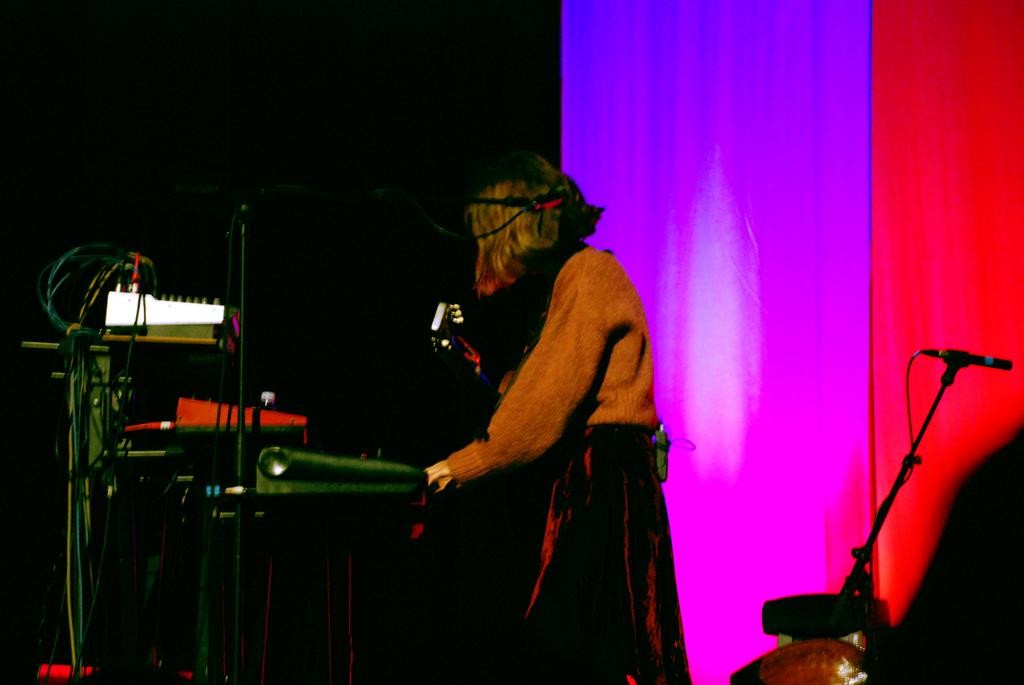What is the person in the image holding? The person is holding a guitar in the image. What else can be seen in the image besides the person with the guitar? There are musical instruments and a cloth in the image. How would you describe the lighting in the image? The background of the image is dark. Can you see a donkey moving in the background of the image? There is no donkey present in the image, and therefore no such movement can be observed. 